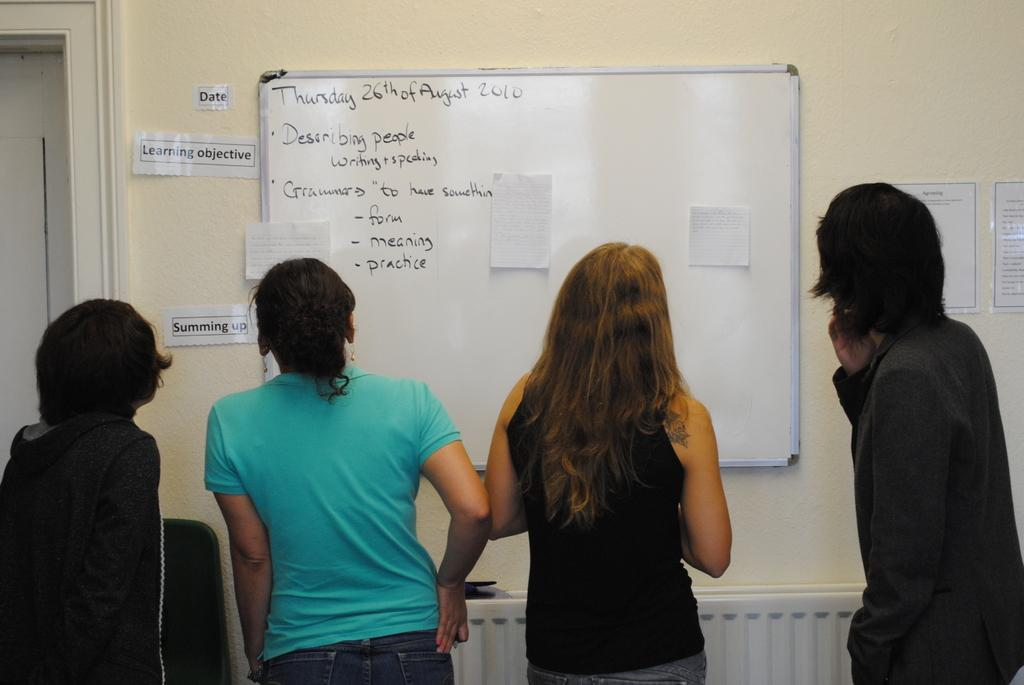<image>
Describe the image concisely. A whiteboard is dated Thursday, 26th August, 2010. 